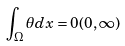Convert formula to latex. <formula><loc_0><loc_0><loc_500><loc_500>\int _ { \Omega } \theta d x = 0 ( 0 , \infty )</formula> 